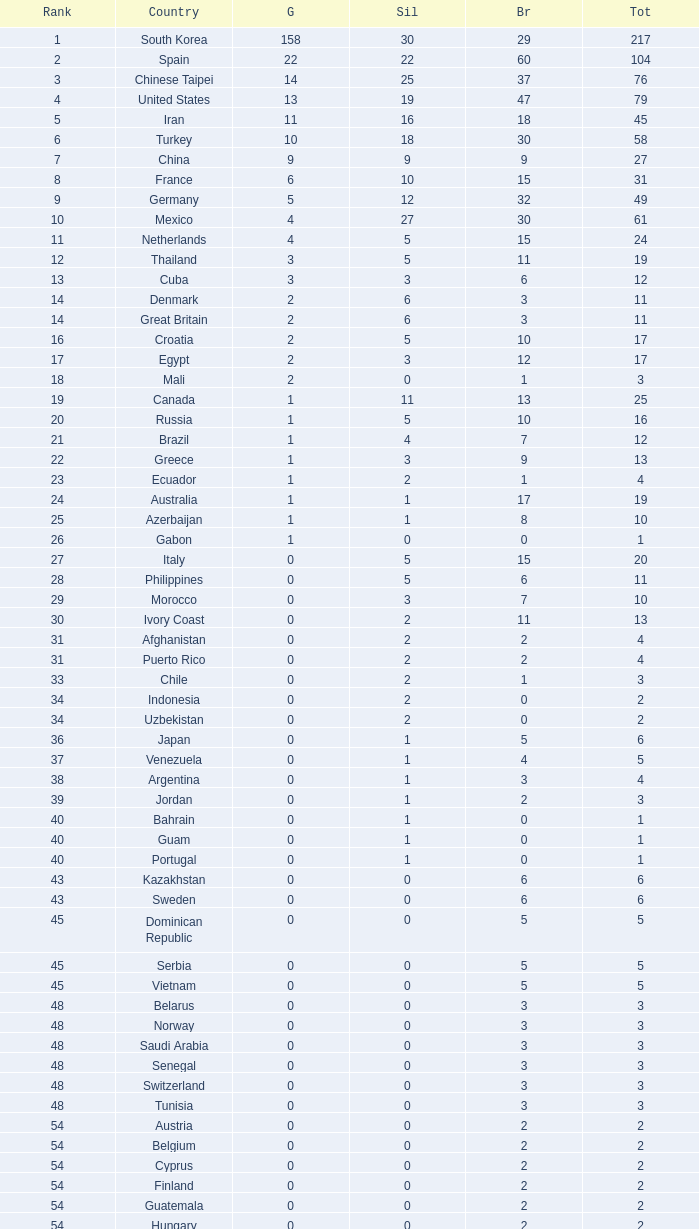What is the Total medals for the Nation ranking 33 with more than 1 Bronze? None. 